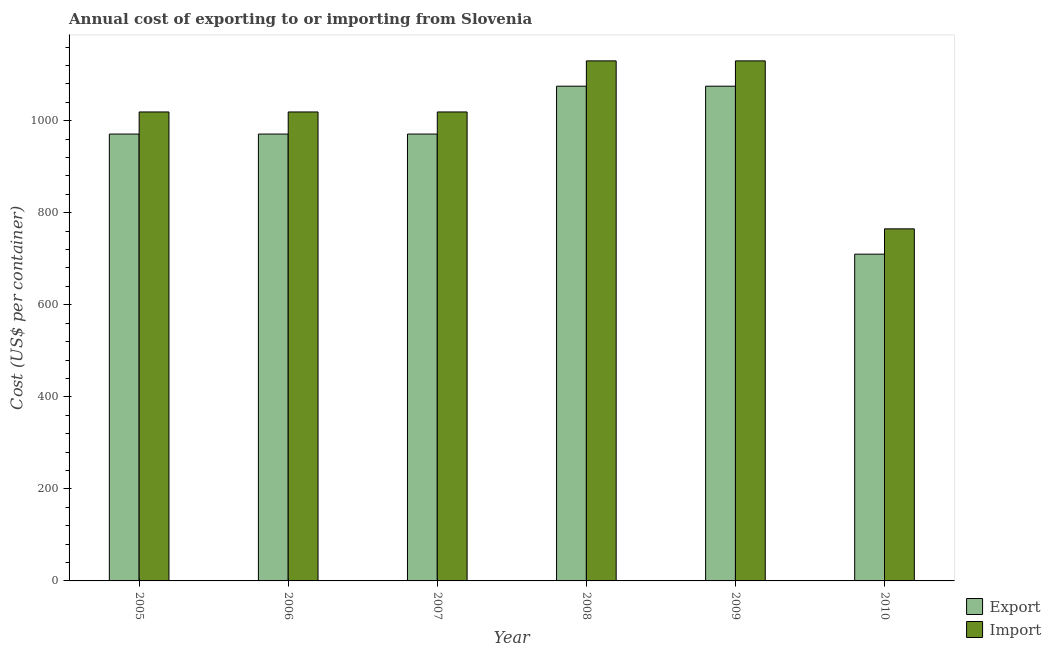How many different coloured bars are there?
Make the answer very short. 2. Are the number of bars on each tick of the X-axis equal?
Give a very brief answer. Yes. What is the import cost in 2009?
Offer a terse response. 1130. Across all years, what is the maximum export cost?
Your answer should be compact. 1075. Across all years, what is the minimum import cost?
Your answer should be compact. 765. In which year was the export cost minimum?
Ensure brevity in your answer.  2010. What is the total import cost in the graph?
Provide a succinct answer. 6082. What is the difference between the import cost in 2005 and that in 2009?
Your answer should be compact. -111. What is the difference between the export cost in 2006 and the import cost in 2010?
Your answer should be compact. 261. What is the average export cost per year?
Your answer should be very brief. 962.17. In the year 2008, what is the difference between the import cost and export cost?
Make the answer very short. 0. In how many years, is the import cost greater than 320 US$?
Your answer should be compact. 6. What is the ratio of the import cost in 2005 to that in 2010?
Offer a terse response. 1.33. What is the difference between the highest and the second highest import cost?
Offer a terse response. 0. What is the difference between the highest and the lowest export cost?
Your answer should be compact. 365. In how many years, is the export cost greater than the average export cost taken over all years?
Offer a terse response. 5. What does the 2nd bar from the left in 2007 represents?
Keep it short and to the point. Import. What does the 2nd bar from the right in 2007 represents?
Your answer should be compact. Export. Are all the bars in the graph horizontal?
Offer a terse response. No. How many years are there in the graph?
Your answer should be compact. 6. Are the values on the major ticks of Y-axis written in scientific E-notation?
Provide a succinct answer. No. What is the title of the graph?
Give a very brief answer. Annual cost of exporting to or importing from Slovenia. Does "Female" appear as one of the legend labels in the graph?
Provide a succinct answer. No. What is the label or title of the X-axis?
Provide a short and direct response. Year. What is the label or title of the Y-axis?
Give a very brief answer. Cost (US$ per container). What is the Cost (US$ per container) of Export in 2005?
Ensure brevity in your answer.  971. What is the Cost (US$ per container) in Import in 2005?
Make the answer very short. 1019. What is the Cost (US$ per container) of Export in 2006?
Make the answer very short. 971. What is the Cost (US$ per container) of Import in 2006?
Offer a terse response. 1019. What is the Cost (US$ per container) in Export in 2007?
Provide a succinct answer. 971. What is the Cost (US$ per container) of Import in 2007?
Your answer should be compact. 1019. What is the Cost (US$ per container) of Export in 2008?
Provide a short and direct response. 1075. What is the Cost (US$ per container) of Import in 2008?
Ensure brevity in your answer.  1130. What is the Cost (US$ per container) in Export in 2009?
Offer a terse response. 1075. What is the Cost (US$ per container) of Import in 2009?
Keep it short and to the point. 1130. What is the Cost (US$ per container) in Export in 2010?
Your answer should be very brief. 710. What is the Cost (US$ per container) in Import in 2010?
Make the answer very short. 765. Across all years, what is the maximum Cost (US$ per container) in Export?
Offer a terse response. 1075. Across all years, what is the maximum Cost (US$ per container) of Import?
Keep it short and to the point. 1130. Across all years, what is the minimum Cost (US$ per container) in Export?
Give a very brief answer. 710. Across all years, what is the minimum Cost (US$ per container) of Import?
Your response must be concise. 765. What is the total Cost (US$ per container) in Export in the graph?
Make the answer very short. 5773. What is the total Cost (US$ per container) of Import in the graph?
Provide a succinct answer. 6082. What is the difference between the Cost (US$ per container) in Export in 2005 and that in 2008?
Provide a short and direct response. -104. What is the difference between the Cost (US$ per container) in Import in 2005 and that in 2008?
Ensure brevity in your answer.  -111. What is the difference between the Cost (US$ per container) in Export in 2005 and that in 2009?
Your answer should be very brief. -104. What is the difference between the Cost (US$ per container) in Import in 2005 and that in 2009?
Offer a very short reply. -111. What is the difference between the Cost (US$ per container) of Export in 2005 and that in 2010?
Your answer should be very brief. 261. What is the difference between the Cost (US$ per container) in Import in 2005 and that in 2010?
Give a very brief answer. 254. What is the difference between the Cost (US$ per container) in Export in 2006 and that in 2007?
Provide a short and direct response. 0. What is the difference between the Cost (US$ per container) of Import in 2006 and that in 2007?
Give a very brief answer. 0. What is the difference between the Cost (US$ per container) of Export in 2006 and that in 2008?
Offer a very short reply. -104. What is the difference between the Cost (US$ per container) of Import in 2006 and that in 2008?
Your response must be concise. -111. What is the difference between the Cost (US$ per container) in Export in 2006 and that in 2009?
Your answer should be very brief. -104. What is the difference between the Cost (US$ per container) in Import in 2006 and that in 2009?
Your answer should be compact. -111. What is the difference between the Cost (US$ per container) of Export in 2006 and that in 2010?
Your answer should be compact. 261. What is the difference between the Cost (US$ per container) of Import in 2006 and that in 2010?
Your answer should be very brief. 254. What is the difference between the Cost (US$ per container) in Export in 2007 and that in 2008?
Provide a succinct answer. -104. What is the difference between the Cost (US$ per container) of Import in 2007 and that in 2008?
Provide a short and direct response. -111. What is the difference between the Cost (US$ per container) in Export in 2007 and that in 2009?
Your answer should be very brief. -104. What is the difference between the Cost (US$ per container) in Import in 2007 and that in 2009?
Offer a terse response. -111. What is the difference between the Cost (US$ per container) of Export in 2007 and that in 2010?
Your response must be concise. 261. What is the difference between the Cost (US$ per container) in Import in 2007 and that in 2010?
Provide a succinct answer. 254. What is the difference between the Cost (US$ per container) of Export in 2008 and that in 2009?
Your answer should be very brief. 0. What is the difference between the Cost (US$ per container) in Export in 2008 and that in 2010?
Provide a succinct answer. 365. What is the difference between the Cost (US$ per container) of Import in 2008 and that in 2010?
Offer a terse response. 365. What is the difference between the Cost (US$ per container) of Export in 2009 and that in 2010?
Make the answer very short. 365. What is the difference between the Cost (US$ per container) of Import in 2009 and that in 2010?
Your answer should be very brief. 365. What is the difference between the Cost (US$ per container) in Export in 2005 and the Cost (US$ per container) in Import in 2006?
Offer a terse response. -48. What is the difference between the Cost (US$ per container) of Export in 2005 and the Cost (US$ per container) of Import in 2007?
Provide a short and direct response. -48. What is the difference between the Cost (US$ per container) of Export in 2005 and the Cost (US$ per container) of Import in 2008?
Your answer should be compact. -159. What is the difference between the Cost (US$ per container) of Export in 2005 and the Cost (US$ per container) of Import in 2009?
Your response must be concise. -159. What is the difference between the Cost (US$ per container) in Export in 2005 and the Cost (US$ per container) in Import in 2010?
Your response must be concise. 206. What is the difference between the Cost (US$ per container) of Export in 2006 and the Cost (US$ per container) of Import in 2007?
Your answer should be very brief. -48. What is the difference between the Cost (US$ per container) of Export in 2006 and the Cost (US$ per container) of Import in 2008?
Your answer should be very brief. -159. What is the difference between the Cost (US$ per container) in Export in 2006 and the Cost (US$ per container) in Import in 2009?
Provide a succinct answer. -159. What is the difference between the Cost (US$ per container) of Export in 2006 and the Cost (US$ per container) of Import in 2010?
Make the answer very short. 206. What is the difference between the Cost (US$ per container) in Export in 2007 and the Cost (US$ per container) in Import in 2008?
Give a very brief answer. -159. What is the difference between the Cost (US$ per container) in Export in 2007 and the Cost (US$ per container) in Import in 2009?
Provide a short and direct response. -159. What is the difference between the Cost (US$ per container) in Export in 2007 and the Cost (US$ per container) in Import in 2010?
Provide a short and direct response. 206. What is the difference between the Cost (US$ per container) of Export in 2008 and the Cost (US$ per container) of Import in 2009?
Your answer should be very brief. -55. What is the difference between the Cost (US$ per container) of Export in 2008 and the Cost (US$ per container) of Import in 2010?
Provide a short and direct response. 310. What is the difference between the Cost (US$ per container) of Export in 2009 and the Cost (US$ per container) of Import in 2010?
Your response must be concise. 310. What is the average Cost (US$ per container) in Export per year?
Make the answer very short. 962.17. What is the average Cost (US$ per container) of Import per year?
Offer a terse response. 1013.67. In the year 2005, what is the difference between the Cost (US$ per container) of Export and Cost (US$ per container) of Import?
Keep it short and to the point. -48. In the year 2006, what is the difference between the Cost (US$ per container) in Export and Cost (US$ per container) in Import?
Offer a terse response. -48. In the year 2007, what is the difference between the Cost (US$ per container) of Export and Cost (US$ per container) of Import?
Give a very brief answer. -48. In the year 2008, what is the difference between the Cost (US$ per container) in Export and Cost (US$ per container) in Import?
Your response must be concise. -55. In the year 2009, what is the difference between the Cost (US$ per container) in Export and Cost (US$ per container) in Import?
Provide a short and direct response. -55. In the year 2010, what is the difference between the Cost (US$ per container) in Export and Cost (US$ per container) in Import?
Your response must be concise. -55. What is the ratio of the Cost (US$ per container) of Export in 2005 to that in 2006?
Provide a succinct answer. 1. What is the ratio of the Cost (US$ per container) in Import in 2005 to that in 2006?
Offer a terse response. 1. What is the ratio of the Cost (US$ per container) of Export in 2005 to that in 2007?
Ensure brevity in your answer.  1. What is the ratio of the Cost (US$ per container) in Export in 2005 to that in 2008?
Offer a terse response. 0.9. What is the ratio of the Cost (US$ per container) in Import in 2005 to that in 2008?
Offer a very short reply. 0.9. What is the ratio of the Cost (US$ per container) of Export in 2005 to that in 2009?
Your answer should be very brief. 0.9. What is the ratio of the Cost (US$ per container) in Import in 2005 to that in 2009?
Make the answer very short. 0.9. What is the ratio of the Cost (US$ per container) of Export in 2005 to that in 2010?
Keep it short and to the point. 1.37. What is the ratio of the Cost (US$ per container) of Import in 2005 to that in 2010?
Ensure brevity in your answer.  1.33. What is the ratio of the Cost (US$ per container) of Export in 2006 to that in 2008?
Provide a short and direct response. 0.9. What is the ratio of the Cost (US$ per container) of Import in 2006 to that in 2008?
Offer a terse response. 0.9. What is the ratio of the Cost (US$ per container) of Export in 2006 to that in 2009?
Keep it short and to the point. 0.9. What is the ratio of the Cost (US$ per container) in Import in 2006 to that in 2009?
Give a very brief answer. 0.9. What is the ratio of the Cost (US$ per container) in Export in 2006 to that in 2010?
Provide a short and direct response. 1.37. What is the ratio of the Cost (US$ per container) of Import in 2006 to that in 2010?
Keep it short and to the point. 1.33. What is the ratio of the Cost (US$ per container) in Export in 2007 to that in 2008?
Ensure brevity in your answer.  0.9. What is the ratio of the Cost (US$ per container) in Import in 2007 to that in 2008?
Ensure brevity in your answer.  0.9. What is the ratio of the Cost (US$ per container) of Export in 2007 to that in 2009?
Offer a very short reply. 0.9. What is the ratio of the Cost (US$ per container) of Import in 2007 to that in 2009?
Make the answer very short. 0.9. What is the ratio of the Cost (US$ per container) of Export in 2007 to that in 2010?
Your response must be concise. 1.37. What is the ratio of the Cost (US$ per container) of Import in 2007 to that in 2010?
Make the answer very short. 1.33. What is the ratio of the Cost (US$ per container) of Export in 2008 to that in 2010?
Give a very brief answer. 1.51. What is the ratio of the Cost (US$ per container) of Import in 2008 to that in 2010?
Your answer should be very brief. 1.48. What is the ratio of the Cost (US$ per container) of Export in 2009 to that in 2010?
Give a very brief answer. 1.51. What is the ratio of the Cost (US$ per container) in Import in 2009 to that in 2010?
Offer a terse response. 1.48. What is the difference between the highest and the lowest Cost (US$ per container) in Export?
Offer a very short reply. 365. What is the difference between the highest and the lowest Cost (US$ per container) of Import?
Your answer should be compact. 365. 